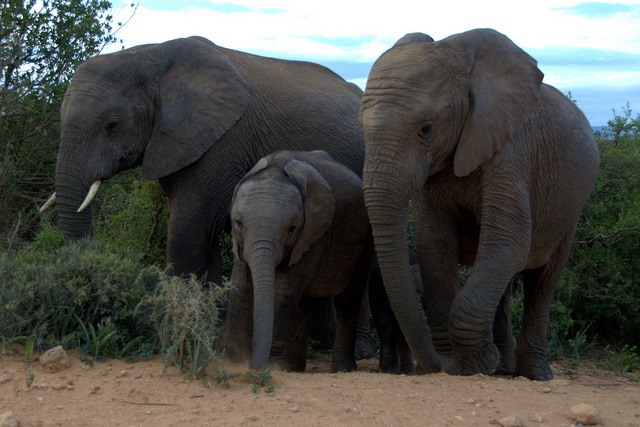Describe the objects in this image and their specific colors. I can see elephant in black and gray tones, elephant in black, gray, and purple tones, and elephant in black and gray tones in this image. 